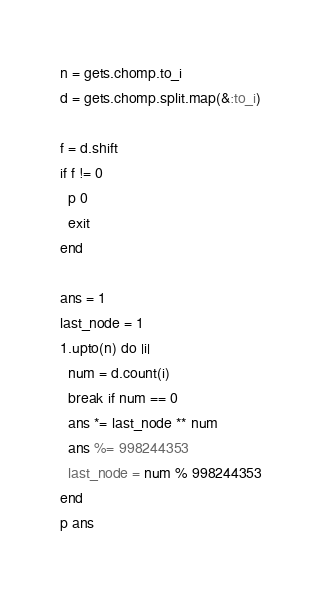<code> <loc_0><loc_0><loc_500><loc_500><_Ruby_>n = gets.chomp.to_i
d = gets.chomp.split.map(&:to_i)

f = d.shift
if f != 0
  p 0
  exit
end

ans = 1
last_node = 1
1.upto(n) do |i|
  num = d.count(i)
  break if num == 0
  ans *= last_node ** num
  ans %= 998244353
  last_node = num % 998244353
end
p ans</code> 